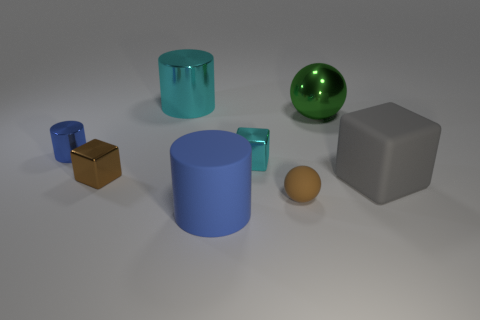Is the number of cubes to the left of the big gray block greater than the number of big spheres?
Your response must be concise. Yes. The large blue matte thing has what shape?
Your answer should be very brief. Cylinder. Do the cylinder that is behind the large green sphere and the cylinder in front of the tiny cylinder have the same color?
Provide a short and direct response. No. Does the small blue shiny thing have the same shape as the green metallic thing?
Make the answer very short. No. Is there anything else that has the same shape as the green metallic thing?
Keep it short and to the point. Yes. Are the cylinder behind the tiny blue thing and the big gray block made of the same material?
Your answer should be compact. No. What is the shape of the large object that is both to the left of the small matte sphere and in front of the big cyan cylinder?
Keep it short and to the point. Cylinder. There is a tiny brown thing in front of the gray rubber thing; are there any matte cubes that are left of it?
Give a very brief answer. No. How many other objects are the same material as the big ball?
Keep it short and to the point. 4. There is a big metal thing that is to the right of the big blue cylinder; does it have the same shape as the brown object on the left side of the brown matte thing?
Keep it short and to the point. No. 